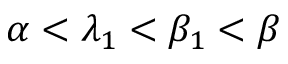Convert formula to latex. <formula><loc_0><loc_0><loc_500><loc_500>\alpha < \lambda _ { 1 } < \beta _ { 1 } < \beta</formula> 